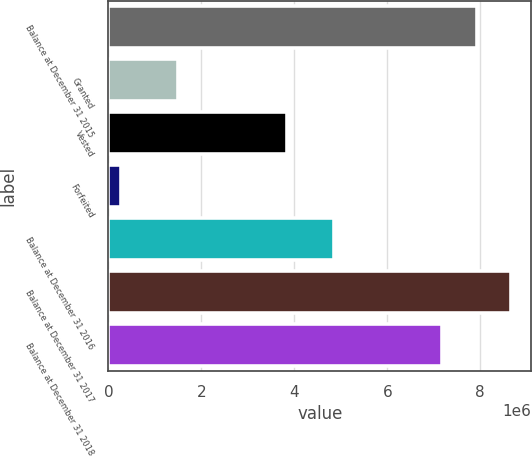<chart> <loc_0><loc_0><loc_500><loc_500><bar_chart><fcel>Balance at December 31 2015<fcel>Granted<fcel>Vested<fcel>Forfeited<fcel>Balance at December 31 2016<fcel>Balance at December 31 2017<fcel>Balance at December 31 2018<nl><fcel>7.92209e+06<fcel>1.49641e+06<fcel>3.84038e+06<fcel>279821<fcel>4.84327e+06<fcel>8.66182e+06<fcel>7.18236e+06<nl></chart> 